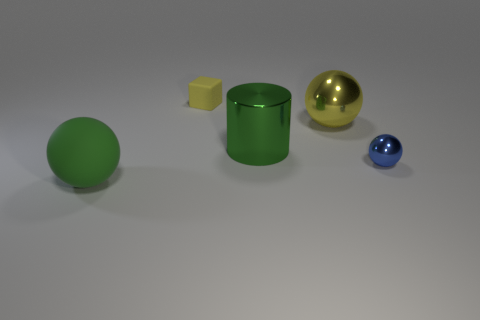Add 3 large green balls. How many objects exist? 8 Subtract all blocks. How many objects are left? 4 Subtract 0 red blocks. How many objects are left? 5 Subtract all red rubber cylinders. Subtract all big shiny things. How many objects are left? 3 Add 4 big green rubber objects. How many big green rubber objects are left? 5 Add 4 tiny red cylinders. How many tiny red cylinders exist? 4 